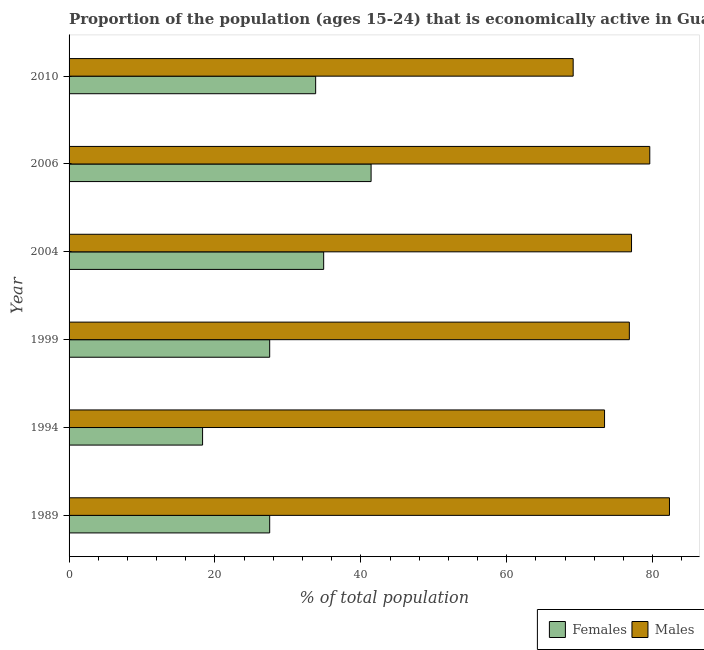How many groups of bars are there?
Your response must be concise. 6. Are the number of bars per tick equal to the number of legend labels?
Your answer should be very brief. Yes. Are the number of bars on each tick of the Y-axis equal?
Keep it short and to the point. Yes. How many bars are there on the 6th tick from the top?
Your response must be concise. 2. How many bars are there on the 4th tick from the bottom?
Your answer should be compact. 2. What is the label of the 1st group of bars from the top?
Give a very brief answer. 2010. In how many cases, is the number of bars for a given year not equal to the number of legend labels?
Ensure brevity in your answer.  0. What is the percentage of economically active female population in 2006?
Your answer should be compact. 41.4. Across all years, what is the maximum percentage of economically active female population?
Keep it short and to the point. 41.4. Across all years, what is the minimum percentage of economically active male population?
Your answer should be compact. 69.1. What is the total percentage of economically active male population in the graph?
Provide a short and direct response. 458.3. What is the difference between the percentage of economically active female population in 1994 and that in 2004?
Offer a very short reply. -16.6. What is the difference between the percentage of economically active female population in 1989 and the percentage of economically active male population in 1999?
Provide a short and direct response. -49.3. What is the average percentage of economically active male population per year?
Your answer should be very brief. 76.38. In the year 1999, what is the difference between the percentage of economically active female population and percentage of economically active male population?
Provide a short and direct response. -49.3. What is the ratio of the percentage of economically active male population in 1994 to that in 2006?
Give a very brief answer. 0.92. Is the percentage of economically active male population in 1989 less than that in 2010?
Offer a very short reply. No. In how many years, is the percentage of economically active female population greater than the average percentage of economically active female population taken over all years?
Offer a terse response. 3. What does the 2nd bar from the top in 2006 represents?
Your answer should be compact. Females. What does the 2nd bar from the bottom in 1999 represents?
Keep it short and to the point. Males. How many bars are there?
Keep it short and to the point. 12. How many years are there in the graph?
Provide a succinct answer. 6. What is the difference between two consecutive major ticks on the X-axis?
Your answer should be compact. 20. Are the values on the major ticks of X-axis written in scientific E-notation?
Your response must be concise. No. Does the graph contain any zero values?
Provide a succinct answer. No. Does the graph contain grids?
Ensure brevity in your answer.  No. What is the title of the graph?
Your response must be concise. Proportion of the population (ages 15-24) that is economically active in Guatemala. What is the label or title of the X-axis?
Offer a terse response. % of total population. What is the label or title of the Y-axis?
Keep it short and to the point. Year. What is the % of total population of Males in 1989?
Provide a succinct answer. 82.3. What is the % of total population in Females in 1994?
Your answer should be compact. 18.3. What is the % of total population of Males in 1994?
Provide a succinct answer. 73.4. What is the % of total population in Males in 1999?
Ensure brevity in your answer.  76.8. What is the % of total population of Females in 2004?
Provide a succinct answer. 34.9. What is the % of total population in Males in 2004?
Your answer should be very brief. 77.1. What is the % of total population in Females in 2006?
Your answer should be compact. 41.4. What is the % of total population in Males in 2006?
Your response must be concise. 79.6. What is the % of total population of Females in 2010?
Provide a succinct answer. 33.8. What is the % of total population of Males in 2010?
Keep it short and to the point. 69.1. Across all years, what is the maximum % of total population in Females?
Your response must be concise. 41.4. Across all years, what is the maximum % of total population of Males?
Keep it short and to the point. 82.3. Across all years, what is the minimum % of total population of Females?
Give a very brief answer. 18.3. Across all years, what is the minimum % of total population of Males?
Give a very brief answer. 69.1. What is the total % of total population in Females in the graph?
Provide a succinct answer. 183.4. What is the total % of total population of Males in the graph?
Your response must be concise. 458.3. What is the difference between the % of total population in Females in 1989 and that in 1994?
Your answer should be compact. 9.2. What is the difference between the % of total population of Males in 1989 and that in 2004?
Make the answer very short. 5.2. What is the difference between the % of total population of Females in 1989 and that in 2010?
Make the answer very short. -6.3. What is the difference between the % of total population of Males in 1989 and that in 2010?
Your answer should be very brief. 13.2. What is the difference between the % of total population of Females in 1994 and that in 1999?
Your response must be concise. -9.2. What is the difference between the % of total population in Females in 1994 and that in 2004?
Offer a terse response. -16.6. What is the difference between the % of total population in Females in 1994 and that in 2006?
Give a very brief answer. -23.1. What is the difference between the % of total population in Females in 1994 and that in 2010?
Your answer should be compact. -15.5. What is the difference between the % of total population of Males in 1999 and that in 2004?
Keep it short and to the point. -0.3. What is the difference between the % of total population in Females in 1999 and that in 2006?
Your answer should be very brief. -13.9. What is the difference between the % of total population in Males in 1999 and that in 2006?
Provide a succinct answer. -2.8. What is the difference between the % of total population of Females in 1999 and that in 2010?
Your answer should be compact. -6.3. What is the difference between the % of total population in Females in 2004 and that in 2006?
Your answer should be very brief. -6.5. What is the difference between the % of total population of Females in 2004 and that in 2010?
Your response must be concise. 1.1. What is the difference between the % of total population in Males in 2004 and that in 2010?
Give a very brief answer. 8. What is the difference between the % of total population in Females in 1989 and the % of total population in Males in 1994?
Offer a terse response. -45.9. What is the difference between the % of total population in Females in 1989 and the % of total population in Males in 1999?
Provide a short and direct response. -49.3. What is the difference between the % of total population of Females in 1989 and the % of total population of Males in 2004?
Make the answer very short. -49.6. What is the difference between the % of total population of Females in 1989 and the % of total population of Males in 2006?
Provide a short and direct response. -52.1. What is the difference between the % of total population in Females in 1989 and the % of total population in Males in 2010?
Provide a succinct answer. -41.6. What is the difference between the % of total population of Females in 1994 and the % of total population of Males in 1999?
Your answer should be compact. -58.5. What is the difference between the % of total population of Females in 1994 and the % of total population of Males in 2004?
Offer a very short reply. -58.8. What is the difference between the % of total population of Females in 1994 and the % of total population of Males in 2006?
Offer a very short reply. -61.3. What is the difference between the % of total population in Females in 1994 and the % of total population in Males in 2010?
Offer a terse response. -50.8. What is the difference between the % of total population of Females in 1999 and the % of total population of Males in 2004?
Your answer should be very brief. -49.6. What is the difference between the % of total population of Females in 1999 and the % of total population of Males in 2006?
Your answer should be very brief. -52.1. What is the difference between the % of total population in Females in 1999 and the % of total population in Males in 2010?
Make the answer very short. -41.6. What is the difference between the % of total population of Females in 2004 and the % of total population of Males in 2006?
Give a very brief answer. -44.7. What is the difference between the % of total population in Females in 2004 and the % of total population in Males in 2010?
Give a very brief answer. -34.2. What is the difference between the % of total population of Females in 2006 and the % of total population of Males in 2010?
Keep it short and to the point. -27.7. What is the average % of total population in Females per year?
Offer a very short reply. 30.57. What is the average % of total population of Males per year?
Provide a succinct answer. 76.38. In the year 1989, what is the difference between the % of total population in Females and % of total population in Males?
Your answer should be compact. -54.8. In the year 1994, what is the difference between the % of total population in Females and % of total population in Males?
Provide a succinct answer. -55.1. In the year 1999, what is the difference between the % of total population of Females and % of total population of Males?
Ensure brevity in your answer.  -49.3. In the year 2004, what is the difference between the % of total population in Females and % of total population in Males?
Offer a terse response. -42.2. In the year 2006, what is the difference between the % of total population of Females and % of total population of Males?
Offer a very short reply. -38.2. In the year 2010, what is the difference between the % of total population of Females and % of total population of Males?
Give a very brief answer. -35.3. What is the ratio of the % of total population of Females in 1989 to that in 1994?
Ensure brevity in your answer.  1.5. What is the ratio of the % of total population of Males in 1989 to that in 1994?
Offer a terse response. 1.12. What is the ratio of the % of total population of Males in 1989 to that in 1999?
Your response must be concise. 1.07. What is the ratio of the % of total population of Females in 1989 to that in 2004?
Ensure brevity in your answer.  0.79. What is the ratio of the % of total population of Males in 1989 to that in 2004?
Keep it short and to the point. 1.07. What is the ratio of the % of total population of Females in 1989 to that in 2006?
Provide a succinct answer. 0.66. What is the ratio of the % of total population in Males in 1989 to that in 2006?
Offer a very short reply. 1.03. What is the ratio of the % of total population of Females in 1989 to that in 2010?
Ensure brevity in your answer.  0.81. What is the ratio of the % of total population of Males in 1989 to that in 2010?
Make the answer very short. 1.19. What is the ratio of the % of total population of Females in 1994 to that in 1999?
Your answer should be compact. 0.67. What is the ratio of the % of total population in Males in 1994 to that in 1999?
Ensure brevity in your answer.  0.96. What is the ratio of the % of total population of Females in 1994 to that in 2004?
Give a very brief answer. 0.52. What is the ratio of the % of total population of Males in 1994 to that in 2004?
Ensure brevity in your answer.  0.95. What is the ratio of the % of total population of Females in 1994 to that in 2006?
Keep it short and to the point. 0.44. What is the ratio of the % of total population of Males in 1994 to that in 2006?
Ensure brevity in your answer.  0.92. What is the ratio of the % of total population in Females in 1994 to that in 2010?
Make the answer very short. 0.54. What is the ratio of the % of total population of Males in 1994 to that in 2010?
Provide a short and direct response. 1.06. What is the ratio of the % of total population in Females in 1999 to that in 2004?
Give a very brief answer. 0.79. What is the ratio of the % of total population in Males in 1999 to that in 2004?
Your response must be concise. 1. What is the ratio of the % of total population of Females in 1999 to that in 2006?
Offer a terse response. 0.66. What is the ratio of the % of total population in Males in 1999 to that in 2006?
Offer a terse response. 0.96. What is the ratio of the % of total population in Females in 1999 to that in 2010?
Make the answer very short. 0.81. What is the ratio of the % of total population of Males in 1999 to that in 2010?
Provide a succinct answer. 1.11. What is the ratio of the % of total population in Females in 2004 to that in 2006?
Your answer should be compact. 0.84. What is the ratio of the % of total population in Males in 2004 to that in 2006?
Provide a short and direct response. 0.97. What is the ratio of the % of total population in Females in 2004 to that in 2010?
Your response must be concise. 1.03. What is the ratio of the % of total population in Males in 2004 to that in 2010?
Offer a terse response. 1.12. What is the ratio of the % of total population in Females in 2006 to that in 2010?
Your answer should be very brief. 1.22. What is the ratio of the % of total population of Males in 2006 to that in 2010?
Your answer should be compact. 1.15. What is the difference between the highest and the second highest % of total population in Males?
Offer a terse response. 2.7. What is the difference between the highest and the lowest % of total population of Females?
Your answer should be very brief. 23.1. What is the difference between the highest and the lowest % of total population of Males?
Provide a short and direct response. 13.2. 